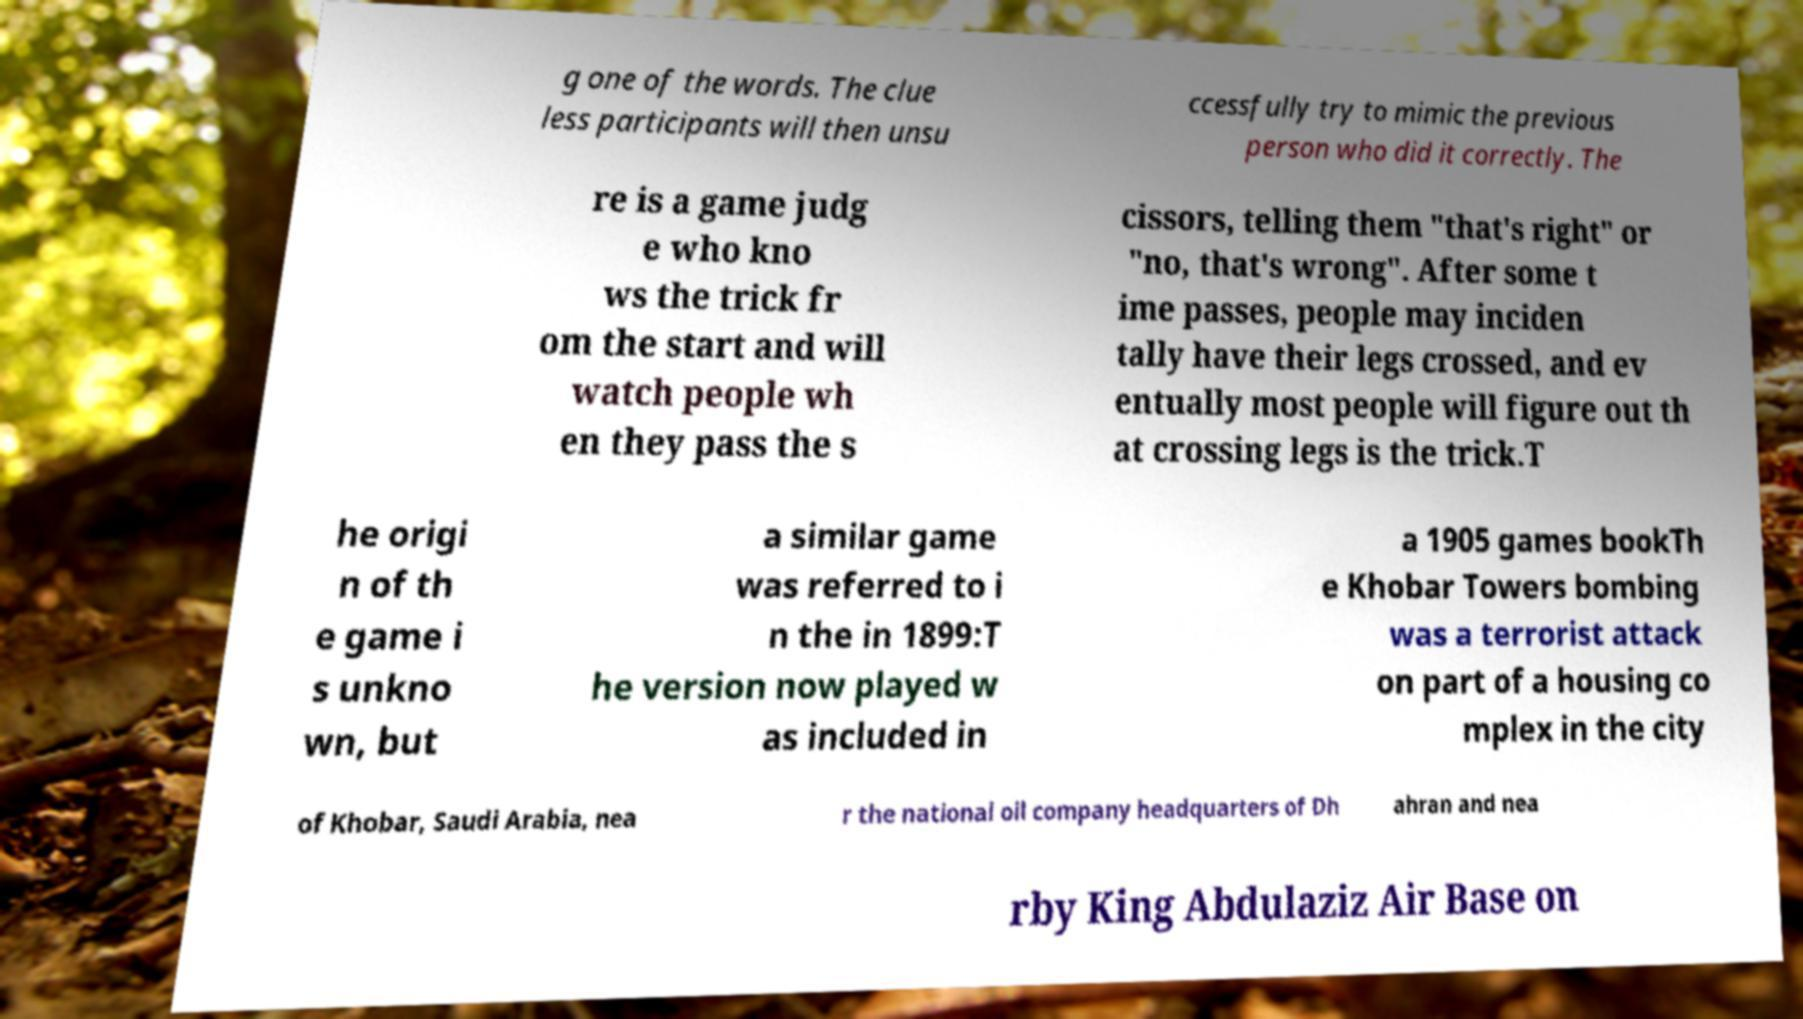There's text embedded in this image that I need extracted. Can you transcribe it verbatim? g one of the words. The clue less participants will then unsu ccessfully try to mimic the previous person who did it correctly. The re is a game judg e who kno ws the trick fr om the start and will watch people wh en they pass the s cissors, telling them "that's right" or "no, that's wrong". After some t ime passes, people may inciden tally have their legs crossed, and ev entually most people will figure out th at crossing legs is the trick.T he origi n of th e game i s unkno wn, but a similar game was referred to i n the in 1899:T he version now played w as included in a 1905 games bookTh e Khobar Towers bombing was a terrorist attack on part of a housing co mplex in the city of Khobar, Saudi Arabia, nea r the national oil company headquarters of Dh ahran and nea rby King Abdulaziz Air Base on 